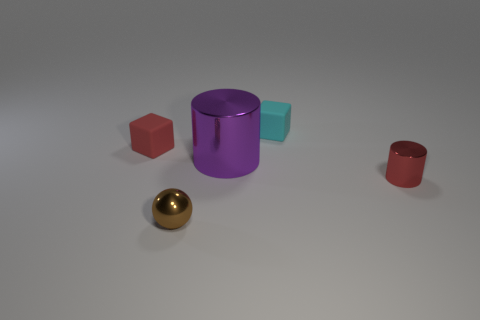What is the tiny red object that is right of the sphere made of?
Make the answer very short. Metal. Is the brown metal object the same shape as the large metallic object?
Provide a short and direct response. No. Is there any other thing that has the same color as the big cylinder?
Give a very brief answer. No. The other matte object that is the same shape as the tiny cyan rubber object is what color?
Give a very brief answer. Red. Are there more brown metallic spheres to the left of the large purple metallic thing than large purple matte objects?
Provide a succinct answer. Yes. There is a block right of the ball; what color is it?
Make the answer very short. Cyan. Is the brown thing the same size as the purple cylinder?
Make the answer very short. No. How big is the purple cylinder?
Make the answer very short. Large. What is the shape of the tiny object that is the same color as the small cylinder?
Your response must be concise. Cube. Is the number of small blue cylinders greater than the number of large metallic objects?
Your answer should be compact. No. 